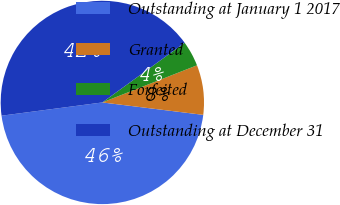<chart> <loc_0><loc_0><loc_500><loc_500><pie_chart><fcel>Outstanding at January 1 2017<fcel>Granted<fcel>Forfeited<fcel>Outstanding at December 31<nl><fcel>45.97%<fcel>7.9%<fcel>4.03%<fcel>42.1%<nl></chart> 